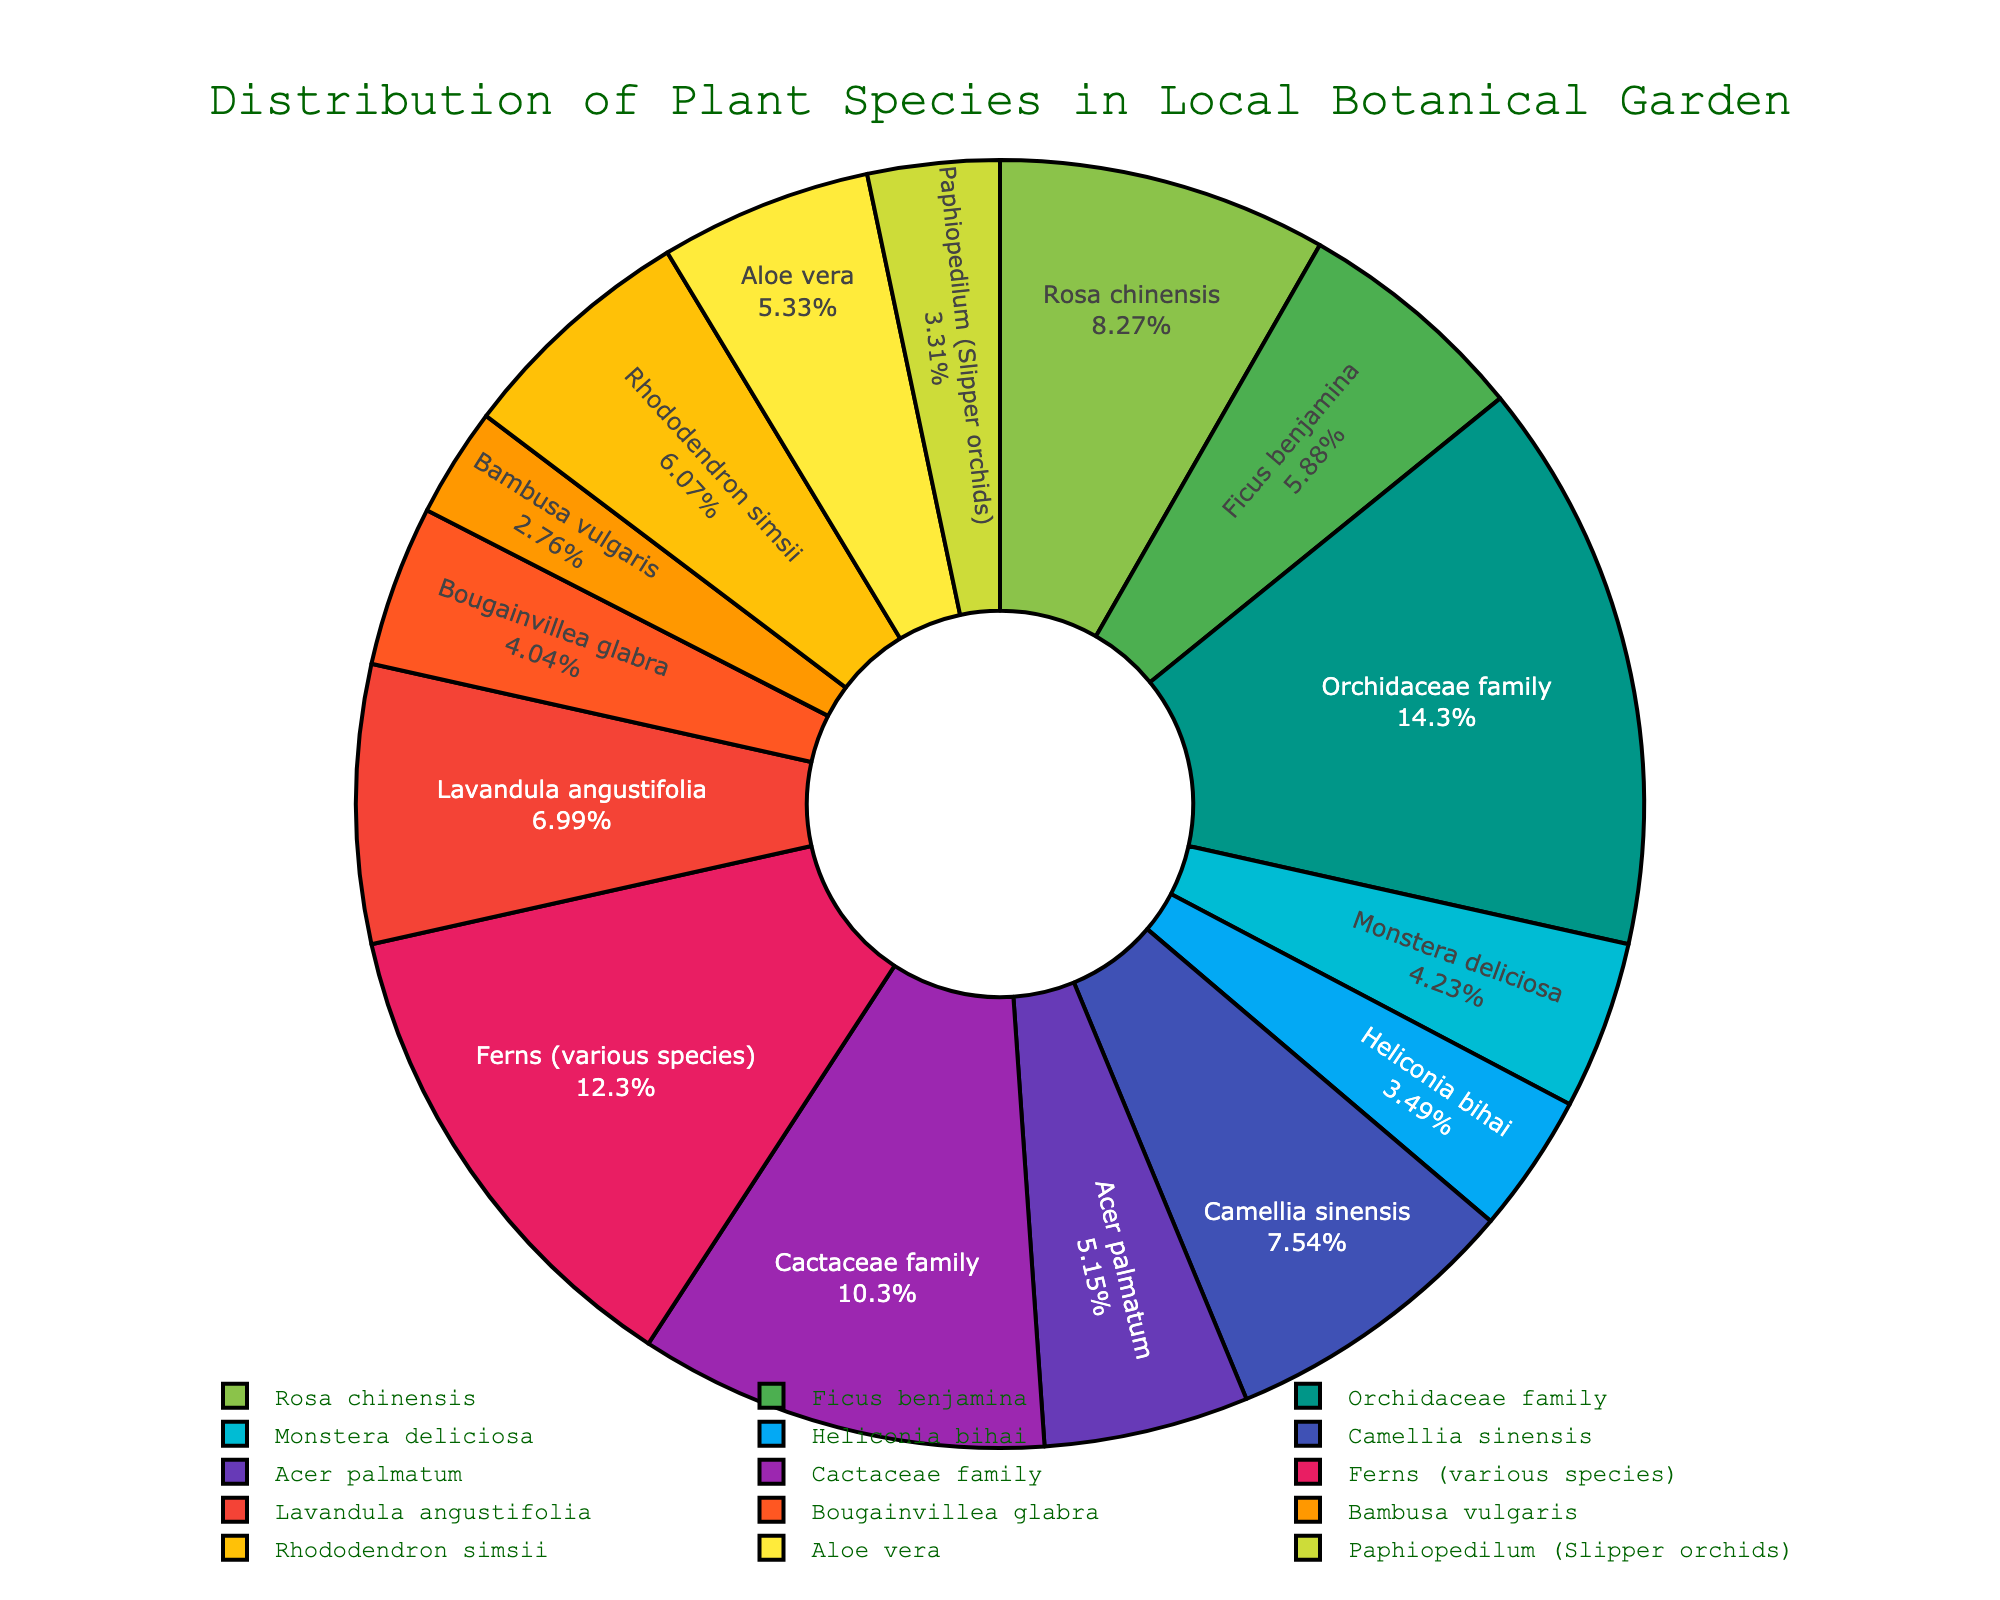Which plant species has the highest number of specimens? By looking at the portions of the pie chart, the "Orchidaceae family" section is the largest. This indicates that the Orchidaceae family has the highest number of specimens.
Answer: Orchidaceae family Which plant species has a greater number of specimens, Rhododendron simsii or Bambusa vulgaris? By comparing the sectors of the pie chart, the slice for "Rhododendron simsii" is larger than the one for "Bambusa vulgaris," indicating that Rhododendron simsii has a greater number of specimens.
Answer: Rhododendron simsii What is the total number of specimens for Rosa chinensis, Camellia sinensis, and Acer palmatum combined? By adding the number of specimens for each of the three species: Rosa chinensis (45), Camellia sinensis (41), and Acer palmatum (28). The total is 45 + 41 + 28 = 114.
Answer: 114 Which color corresponds to the section representing the Cactaceae family? Observing the pie chart, the section labeled "Cactaceae family" is represented by a specific color, which is pinkish-red or a similar shade.
Answer: pinkish-red Which has a smaller number of specimens, Monstera deliciosa or Bougainvillea glabra? By comparing the pie chart slices, we can see that both "Monstera deliciosa" and "Bougainvillea glabra" have similar-sized sections. However, Monstera deliciosa has slightly more specimens than Bougainvillea glabra, thus Bougainvillea glabra has a smaller number of specimens.
Answer: Bougainvillea glabra How many plant species have specimen numbers greater than or equal to 40? Identify sections of the pie chart with specimen numbers: Rosa chinensis (45), Orchidaceae family (78), Camellia sinensis (41), and Cactaceae family (56). There are 4 species.
Answer: 4 Which two species together make up approximately one-third of the total specimen count? Looking at the chart, the sections for Orchidaceae family and Ferns (various species) are large. Combined, they approximate one-third as Orchidaceae family is 78 and Ferns is 67. Their total is 78 + 67 = 145, which is roughly one-third of the total.
Answer: Orchidaceae family and Ferns (various species) What is the percentage of specimens represented by Aloe vera alone? Find the slice corresponding to Aloe vera and look at the percentage. It represents approximately 5% of the total plant specimens.
Answer: 5% 